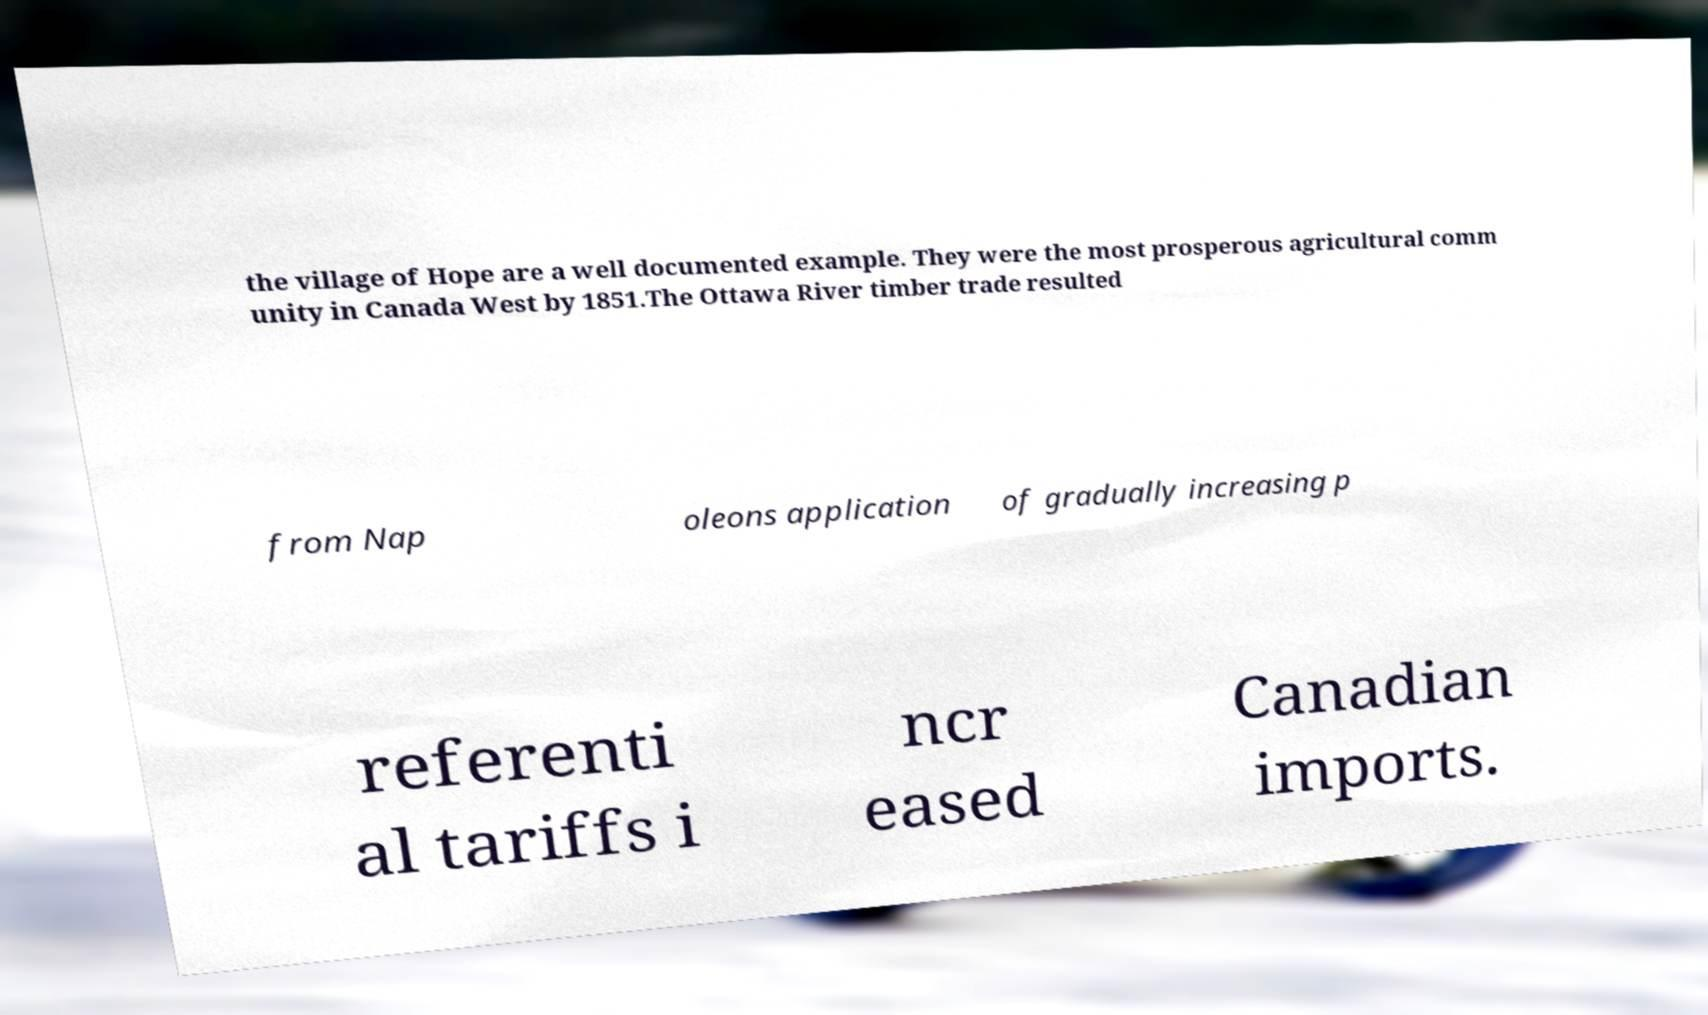Please read and relay the text visible in this image. What does it say? the village of Hope are a well documented example. They were the most prosperous agricultural comm unity in Canada West by 1851.The Ottawa River timber trade resulted from Nap oleons application of gradually increasing p referenti al tariffs i ncr eased Canadian imports. 